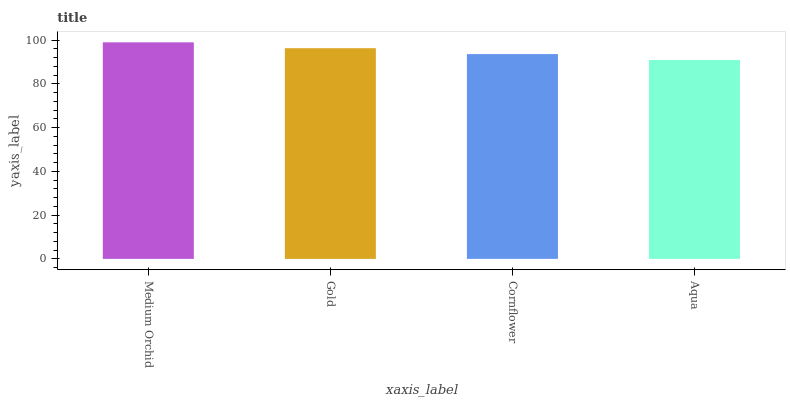Is Aqua the minimum?
Answer yes or no. Yes. Is Medium Orchid the maximum?
Answer yes or no. Yes. Is Gold the minimum?
Answer yes or no. No. Is Gold the maximum?
Answer yes or no. No. Is Medium Orchid greater than Gold?
Answer yes or no. Yes. Is Gold less than Medium Orchid?
Answer yes or no. Yes. Is Gold greater than Medium Orchid?
Answer yes or no. No. Is Medium Orchid less than Gold?
Answer yes or no. No. Is Gold the high median?
Answer yes or no. Yes. Is Cornflower the low median?
Answer yes or no. Yes. Is Cornflower the high median?
Answer yes or no. No. Is Gold the low median?
Answer yes or no. No. 